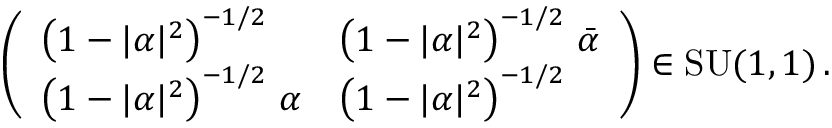<formula> <loc_0><loc_0><loc_500><loc_500>\left ( \begin{array} { l l } { \left ( 1 - | \alpha | ^ { 2 } \right ) ^ { - 1 / 2 } } & { \left ( 1 - | \alpha | ^ { 2 } \right ) ^ { - 1 / 2 } \, \bar { \alpha } } \\ { \left ( 1 - | \alpha | ^ { 2 } \right ) ^ { - 1 / 2 } \, \alpha } & { \left ( 1 - | \alpha | ^ { 2 } \right ) ^ { - 1 / 2 } } \end{array} \right ) \in S U ( 1 , 1 ) \, .</formula> 